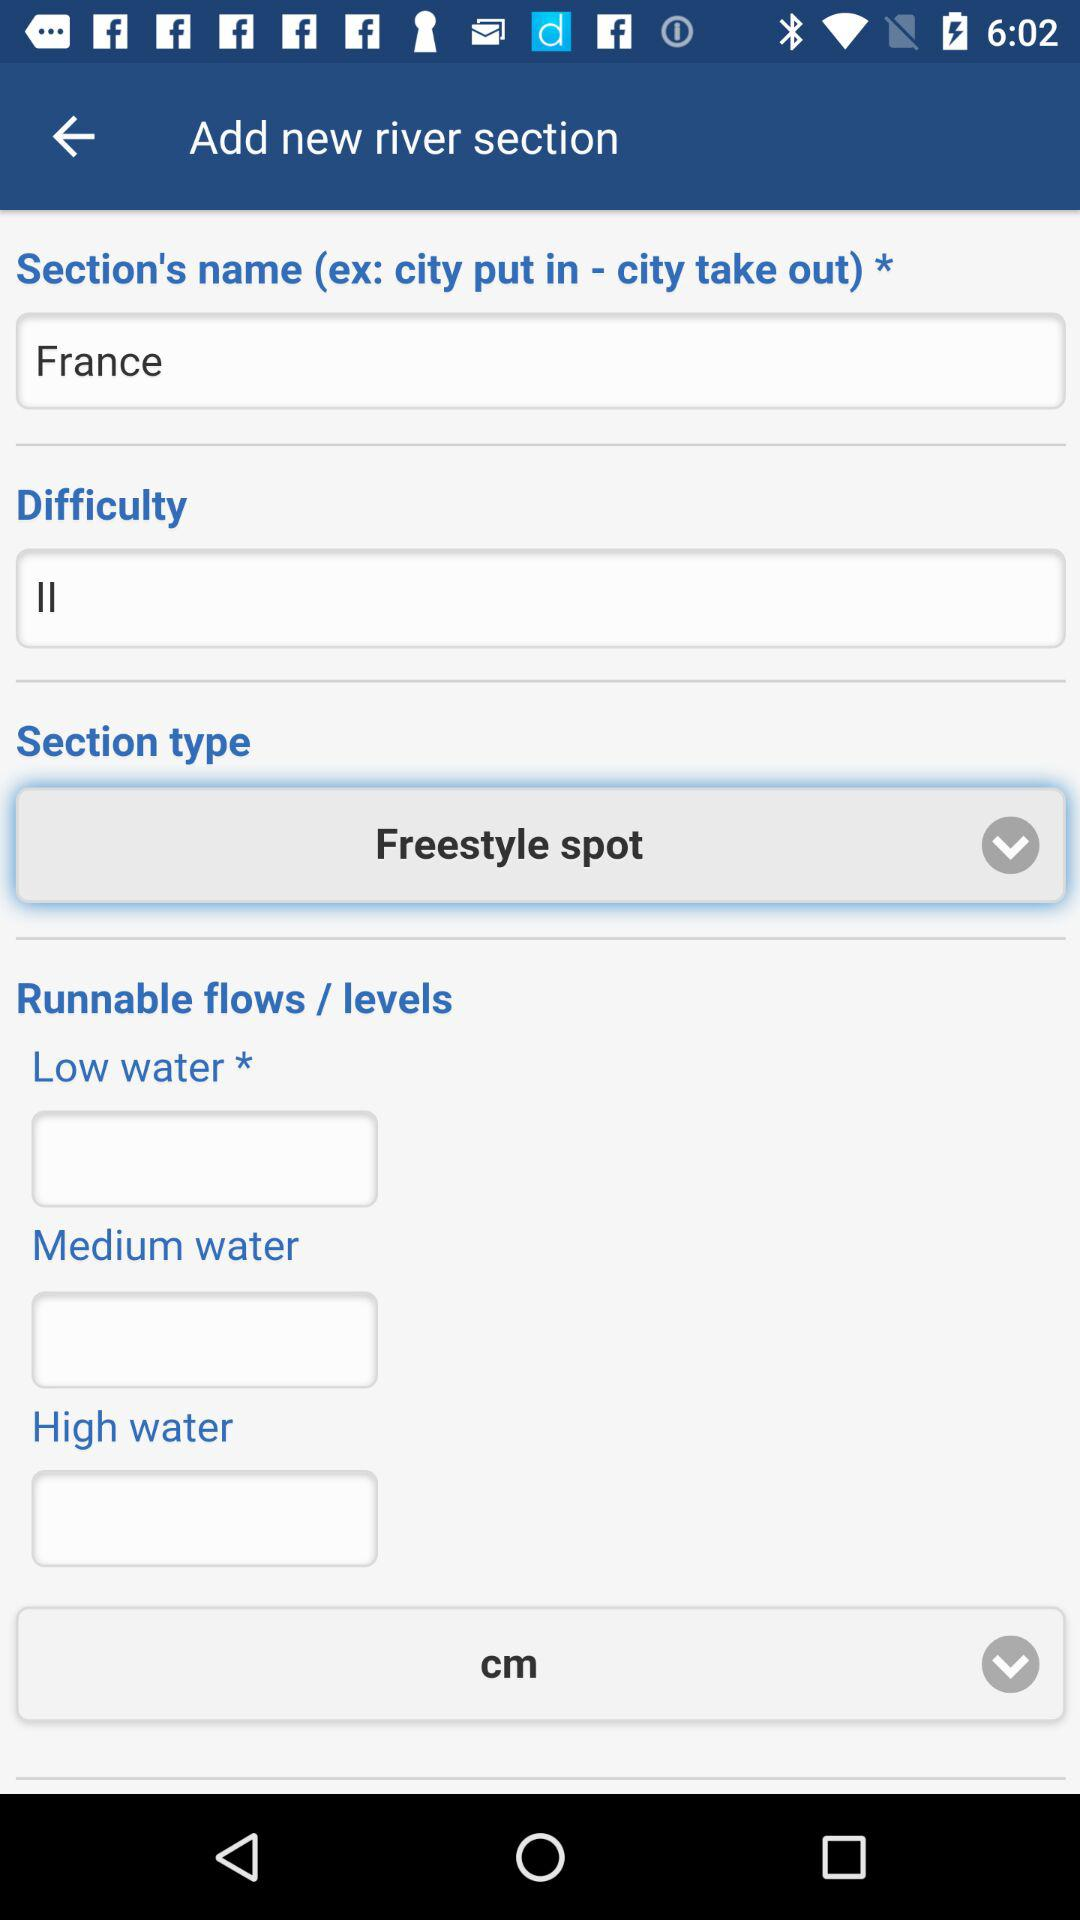How many levels are runnable flows?
When the provided information is insufficient, respond with <no answer>. <no answer> 